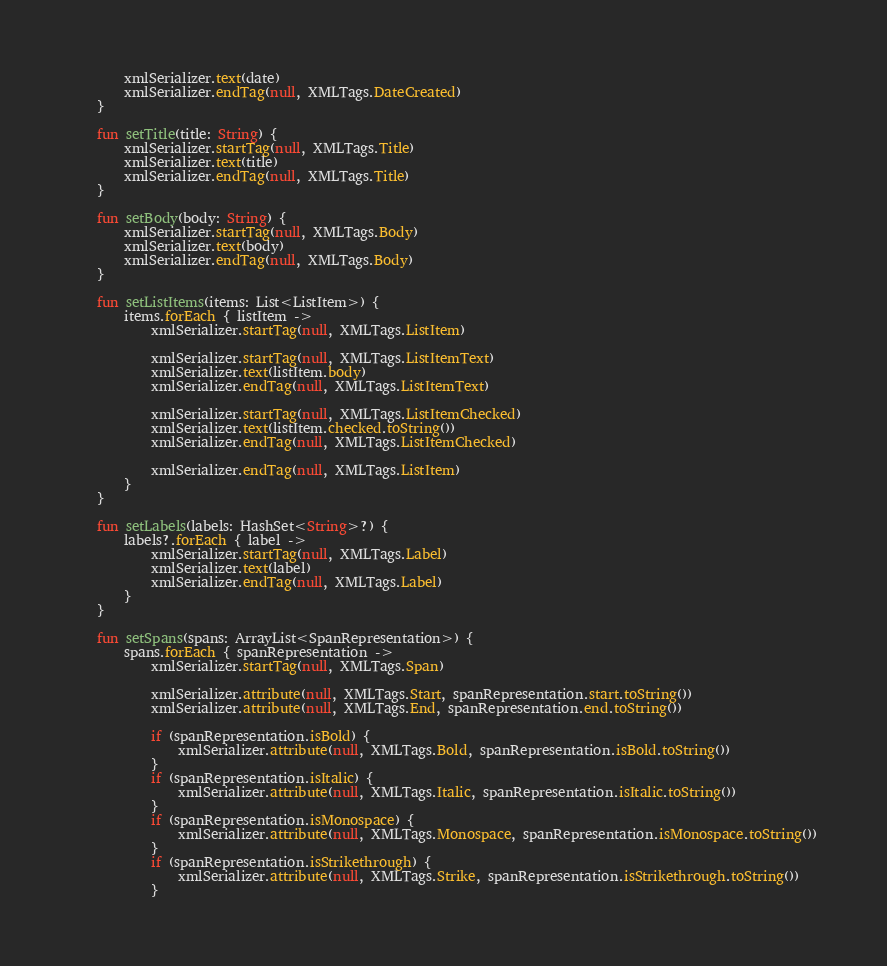<code> <loc_0><loc_0><loc_500><loc_500><_Kotlin_>        xmlSerializer.text(date)
        xmlSerializer.endTag(null, XMLTags.DateCreated)
    }

    fun setTitle(title: String) {
        xmlSerializer.startTag(null, XMLTags.Title)
        xmlSerializer.text(title)
        xmlSerializer.endTag(null, XMLTags.Title)
    }

    fun setBody(body: String) {
        xmlSerializer.startTag(null, XMLTags.Body)
        xmlSerializer.text(body)
        xmlSerializer.endTag(null, XMLTags.Body)
    }

    fun setListItems(items: List<ListItem>) {
        items.forEach { listItem ->
            xmlSerializer.startTag(null, XMLTags.ListItem)

            xmlSerializer.startTag(null, XMLTags.ListItemText)
            xmlSerializer.text(listItem.body)
            xmlSerializer.endTag(null, XMLTags.ListItemText)

            xmlSerializer.startTag(null, XMLTags.ListItemChecked)
            xmlSerializer.text(listItem.checked.toString())
            xmlSerializer.endTag(null, XMLTags.ListItemChecked)

            xmlSerializer.endTag(null, XMLTags.ListItem)
        }
    }

    fun setLabels(labels: HashSet<String>?) {
        labels?.forEach { label ->
            xmlSerializer.startTag(null, XMLTags.Label)
            xmlSerializer.text(label)
            xmlSerializer.endTag(null, XMLTags.Label)
        }
    }

    fun setSpans(spans: ArrayList<SpanRepresentation>) {
        spans.forEach { spanRepresentation ->
            xmlSerializer.startTag(null, XMLTags.Span)

            xmlSerializer.attribute(null, XMLTags.Start, spanRepresentation.start.toString())
            xmlSerializer.attribute(null, XMLTags.End, spanRepresentation.end.toString())

            if (spanRepresentation.isBold) {
                xmlSerializer.attribute(null, XMLTags.Bold, spanRepresentation.isBold.toString())
            }
            if (spanRepresentation.isItalic) {
                xmlSerializer.attribute(null, XMLTags.Italic, spanRepresentation.isItalic.toString())
            }
            if (spanRepresentation.isMonospace) {
                xmlSerializer.attribute(null, XMLTags.Monospace, spanRepresentation.isMonospace.toString())
            }
            if (spanRepresentation.isStrikethrough) {
                xmlSerializer.attribute(null, XMLTags.Strike, spanRepresentation.isStrikethrough.toString())
            }
</code> 